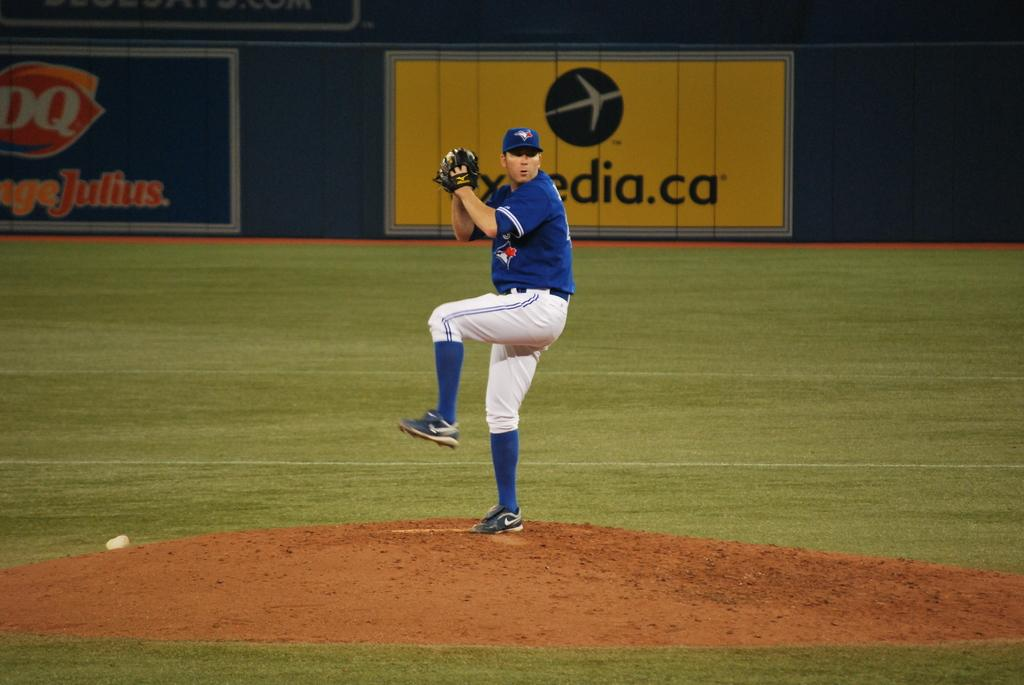What is the main subject of the image? The main subject of the image is a player. Where is the player located in the image? The player is standing on the ground in the image. What is the player holding in his hand? The player is holding a ball in his hand. What can be seen in the background of the image? There is a banner in the background of the image. What is featured on the banner? The banner has text and images on it. What invention is the player using to play in the image? There is no specific invention mentioned or depicted in the image; the player is simply holding a ball. What is the player's nose doing in the image? The player's nose is not mentioned or depicted in the image, as the focus is on the player, the ball, and the banner. 